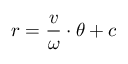<formula> <loc_0><loc_0><loc_500><loc_500>r = { \frac { v } { \omega } } \cdot \theta + c</formula> 